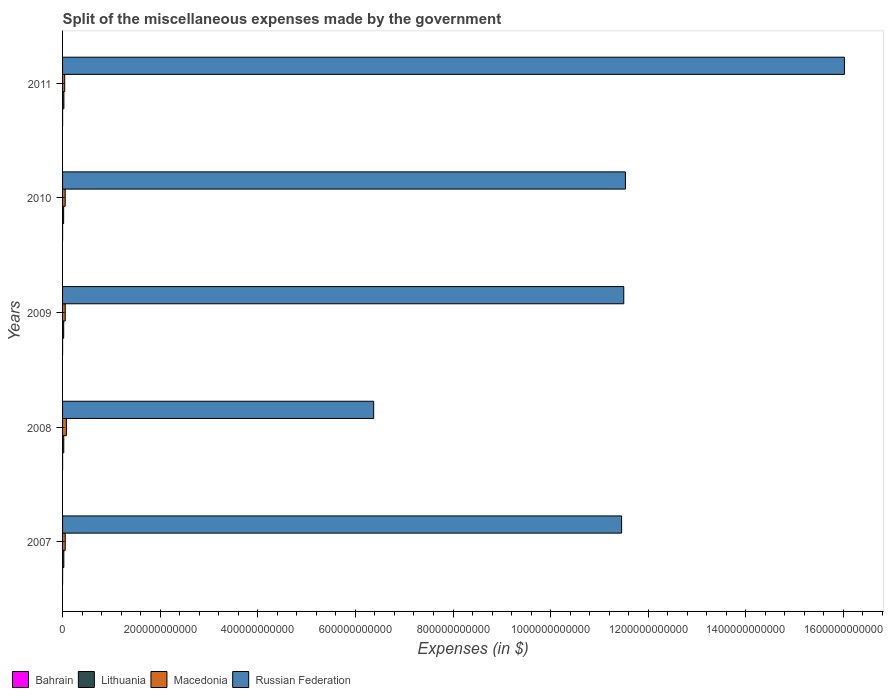How many different coloured bars are there?
Offer a terse response. 4. How many bars are there on the 5th tick from the top?
Give a very brief answer. 4. What is the label of the 3rd group of bars from the top?
Give a very brief answer. 2009. What is the miscellaneous expenses made by the government in Macedonia in 2011?
Offer a terse response. 4.39e+09. Across all years, what is the maximum miscellaneous expenses made by the government in Russian Federation?
Provide a succinct answer. 1.60e+12. Across all years, what is the minimum miscellaneous expenses made by the government in Macedonia?
Keep it short and to the point. 4.39e+09. In which year was the miscellaneous expenses made by the government in Bahrain maximum?
Ensure brevity in your answer.  2007. In which year was the miscellaneous expenses made by the government in Russian Federation minimum?
Ensure brevity in your answer.  2008. What is the total miscellaneous expenses made by the government in Russian Federation in the graph?
Make the answer very short. 5.69e+12. What is the difference between the miscellaneous expenses made by the government in Macedonia in 2009 and that in 2011?
Ensure brevity in your answer.  1.09e+09. What is the difference between the miscellaneous expenses made by the government in Bahrain in 2010 and the miscellaneous expenses made by the government in Macedonia in 2007?
Your response must be concise. -5.44e+09. What is the average miscellaneous expenses made by the government in Bahrain per year?
Keep it short and to the point. 3.77e+07. In the year 2008, what is the difference between the miscellaneous expenses made by the government in Russian Federation and miscellaneous expenses made by the government in Macedonia?
Provide a succinct answer. 6.30e+11. In how many years, is the miscellaneous expenses made by the government in Russian Federation greater than 160000000000 $?
Give a very brief answer. 5. What is the ratio of the miscellaneous expenses made by the government in Lithuania in 2007 to that in 2009?
Make the answer very short. 1.13. Is the difference between the miscellaneous expenses made by the government in Russian Federation in 2007 and 2010 greater than the difference between the miscellaneous expenses made by the government in Macedonia in 2007 and 2010?
Your answer should be compact. No. What is the difference between the highest and the second highest miscellaneous expenses made by the government in Lithuania?
Keep it short and to the point. 1.39e+08. What is the difference between the highest and the lowest miscellaneous expenses made by the government in Russian Federation?
Your answer should be very brief. 9.64e+11. Is the sum of the miscellaneous expenses made by the government in Lithuania in 2010 and 2011 greater than the maximum miscellaneous expenses made by the government in Bahrain across all years?
Make the answer very short. Yes. Is it the case that in every year, the sum of the miscellaneous expenses made by the government in Bahrain and miscellaneous expenses made by the government in Lithuania is greater than the sum of miscellaneous expenses made by the government in Russian Federation and miscellaneous expenses made by the government in Macedonia?
Provide a short and direct response. No. What does the 4th bar from the top in 2010 represents?
Keep it short and to the point. Bahrain. What does the 3rd bar from the bottom in 2010 represents?
Make the answer very short. Macedonia. Is it the case that in every year, the sum of the miscellaneous expenses made by the government in Russian Federation and miscellaneous expenses made by the government in Bahrain is greater than the miscellaneous expenses made by the government in Macedonia?
Keep it short and to the point. Yes. Are all the bars in the graph horizontal?
Make the answer very short. Yes. How many years are there in the graph?
Make the answer very short. 5. What is the difference between two consecutive major ticks on the X-axis?
Your answer should be very brief. 2.00e+11. Does the graph contain any zero values?
Your answer should be very brief. No. How many legend labels are there?
Make the answer very short. 4. What is the title of the graph?
Provide a short and direct response. Split of the miscellaneous expenses made by the government. Does "Virgin Islands" appear as one of the legend labels in the graph?
Your answer should be compact. No. What is the label or title of the X-axis?
Keep it short and to the point. Expenses (in $). What is the Expenses (in $) of Bahrain in 2007?
Offer a terse response. 5.97e+07. What is the Expenses (in $) of Lithuania in 2007?
Give a very brief answer. 2.58e+09. What is the Expenses (in $) in Macedonia in 2007?
Keep it short and to the point. 5.47e+09. What is the Expenses (in $) of Russian Federation in 2007?
Provide a short and direct response. 1.15e+12. What is the Expenses (in $) of Bahrain in 2008?
Your answer should be very brief. 1.90e+07. What is the Expenses (in $) of Lithuania in 2008?
Provide a succinct answer. 2.45e+09. What is the Expenses (in $) of Macedonia in 2008?
Offer a very short reply. 7.88e+09. What is the Expenses (in $) of Russian Federation in 2008?
Your answer should be very brief. 6.38e+11. What is the Expenses (in $) of Bahrain in 2009?
Make the answer very short. 2.67e+07. What is the Expenses (in $) in Lithuania in 2009?
Provide a short and direct response. 2.28e+09. What is the Expenses (in $) of Macedonia in 2009?
Your answer should be very brief. 5.48e+09. What is the Expenses (in $) in Russian Federation in 2009?
Give a very brief answer. 1.15e+12. What is the Expenses (in $) of Bahrain in 2010?
Provide a succinct answer. 2.50e+07. What is the Expenses (in $) of Lithuania in 2010?
Provide a succinct answer. 2.21e+09. What is the Expenses (in $) of Macedonia in 2010?
Provide a short and direct response. 5.39e+09. What is the Expenses (in $) in Russian Federation in 2010?
Your answer should be compact. 1.15e+12. What is the Expenses (in $) in Bahrain in 2011?
Give a very brief answer. 5.82e+07. What is the Expenses (in $) of Lithuania in 2011?
Give a very brief answer. 2.72e+09. What is the Expenses (in $) of Macedonia in 2011?
Make the answer very short. 4.39e+09. What is the Expenses (in $) in Russian Federation in 2011?
Ensure brevity in your answer.  1.60e+12. Across all years, what is the maximum Expenses (in $) of Bahrain?
Offer a very short reply. 5.97e+07. Across all years, what is the maximum Expenses (in $) in Lithuania?
Give a very brief answer. 2.72e+09. Across all years, what is the maximum Expenses (in $) in Macedonia?
Provide a succinct answer. 7.88e+09. Across all years, what is the maximum Expenses (in $) in Russian Federation?
Ensure brevity in your answer.  1.60e+12. Across all years, what is the minimum Expenses (in $) in Bahrain?
Offer a terse response. 1.90e+07. Across all years, what is the minimum Expenses (in $) of Lithuania?
Your answer should be very brief. 2.21e+09. Across all years, what is the minimum Expenses (in $) of Macedonia?
Your answer should be very brief. 4.39e+09. Across all years, what is the minimum Expenses (in $) in Russian Federation?
Your answer should be compact. 6.38e+11. What is the total Expenses (in $) in Bahrain in the graph?
Offer a very short reply. 1.89e+08. What is the total Expenses (in $) in Lithuania in the graph?
Your response must be concise. 1.22e+1. What is the total Expenses (in $) in Macedonia in the graph?
Make the answer very short. 2.86e+1. What is the total Expenses (in $) in Russian Federation in the graph?
Keep it short and to the point. 5.69e+12. What is the difference between the Expenses (in $) in Bahrain in 2007 and that in 2008?
Offer a terse response. 4.07e+07. What is the difference between the Expenses (in $) of Lithuania in 2007 and that in 2008?
Offer a terse response. 1.36e+08. What is the difference between the Expenses (in $) of Macedonia in 2007 and that in 2008?
Offer a terse response. -2.41e+09. What is the difference between the Expenses (in $) of Russian Federation in 2007 and that in 2008?
Make the answer very short. 5.08e+11. What is the difference between the Expenses (in $) in Bahrain in 2007 and that in 2009?
Your response must be concise. 3.30e+07. What is the difference between the Expenses (in $) in Lithuania in 2007 and that in 2009?
Offer a very short reply. 2.99e+08. What is the difference between the Expenses (in $) of Macedonia in 2007 and that in 2009?
Your answer should be compact. -1.40e+07. What is the difference between the Expenses (in $) of Russian Federation in 2007 and that in 2009?
Offer a very short reply. -4.40e+09. What is the difference between the Expenses (in $) in Bahrain in 2007 and that in 2010?
Your response must be concise. 3.47e+07. What is the difference between the Expenses (in $) in Lithuania in 2007 and that in 2010?
Your answer should be very brief. 3.74e+08. What is the difference between the Expenses (in $) in Macedonia in 2007 and that in 2010?
Your response must be concise. 7.30e+07. What is the difference between the Expenses (in $) in Russian Federation in 2007 and that in 2010?
Make the answer very short. -7.80e+09. What is the difference between the Expenses (in $) of Bahrain in 2007 and that in 2011?
Keep it short and to the point. 1.48e+06. What is the difference between the Expenses (in $) in Lithuania in 2007 and that in 2011?
Ensure brevity in your answer.  -1.39e+08. What is the difference between the Expenses (in $) in Macedonia in 2007 and that in 2011?
Keep it short and to the point. 1.08e+09. What is the difference between the Expenses (in $) in Russian Federation in 2007 and that in 2011?
Offer a very short reply. -4.56e+11. What is the difference between the Expenses (in $) of Bahrain in 2008 and that in 2009?
Ensure brevity in your answer.  -7.73e+06. What is the difference between the Expenses (in $) of Lithuania in 2008 and that in 2009?
Your answer should be compact. 1.64e+08. What is the difference between the Expenses (in $) in Macedonia in 2008 and that in 2009?
Keep it short and to the point. 2.40e+09. What is the difference between the Expenses (in $) of Russian Federation in 2008 and that in 2009?
Offer a very short reply. -5.12e+11. What is the difference between the Expenses (in $) of Bahrain in 2008 and that in 2010?
Provide a succinct answer. -6.02e+06. What is the difference between the Expenses (in $) of Lithuania in 2008 and that in 2010?
Your answer should be very brief. 2.38e+08. What is the difference between the Expenses (in $) in Macedonia in 2008 and that in 2010?
Ensure brevity in your answer.  2.48e+09. What is the difference between the Expenses (in $) in Russian Federation in 2008 and that in 2010?
Provide a short and direct response. -5.16e+11. What is the difference between the Expenses (in $) of Bahrain in 2008 and that in 2011?
Ensure brevity in your answer.  -3.92e+07. What is the difference between the Expenses (in $) in Lithuania in 2008 and that in 2011?
Offer a terse response. -2.75e+08. What is the difference between the Expenses (in $) of Macedonia in 2008 and that in 2011?
Give a very brief answer. 3.49e+09. What is the difference between the Expenses (in $) in Russian Federation in 2008 and that in 2011?
Offer a very short reply. -9.64e+11. What is the difference between the Expenses (in $) in Bahrain in 2009 and that in 2010?
Give a very brief answer. 1.71e+06. What is the difference between the Expenses (in $) in Lithuania in 2009 and that in 2010?
Offer a very short reply. 7.48e+07. What is the difference between the Expenses (in $) in Macedonia in 2009 and that in 2010?
Make the answer very short. 8.70e+07. What is the difference between the Expenses (in $) of Russian Federation in 2009 and that in 2010?
Keep it short and to the point. -3.40e+09. What is the difference between the Expenses (in $) of Bahrain in 2009 and that in 2011?
Ensure brevity in your answer.  -3.15e+07. What is the difference between the Expenses (in $) of Lithuania in 2009 and that in 2011?
Give a very brief answer. -4.38e+08. What is the difference between the Expenses (in $) of Macedonia in 2009 and that in 2011?
Your answer should be compact. 1.09e+09. What is the difference between the Expenses (in $) in Russian Federation in 2009 and that in 2011?
Offer a very short reply. -4.52e+11. What is the difference between the Expenses (in $) of Bahrain in 2010 and that in 2011?
Your response must be concise. -3.32e+07. What is the difference between the Expenses (in $) in Lithuania in 2010 and that in 2011?
Keep it short and to the point. -5.13e+08. What is the difference between the Expenses (in $) in Macedonia in 2010 and that in 2011?
Keep it short and to the point. 1.01e+09. What is the difference between the Expenses (in $) in Russian Federation in 2010 and that in 2011?
Provide a short and direct response. -4.49e+11. What is the difference between the Expenses (in $) of Bahrain in 2007 and the Expenses (in $) of Lithuania in 2008?
Your answer should be very brief. -2.39e+09. What is the difference between the Expenses (in $) of Bahrain in 2007 and the Expenses (in $) of Macedonia in 2008?
Offer a terse response. -7.82e+09. What is the difference between the Expenses (in $) in Bahrain in 2007 and the Expenses (in $) in Russian Federation in 2008?
Your answer should be very brief. -6.37e+11. What is the difference between the Expenses (in $) in Lithuania in 2007 and the Expenses (in $) in Macedonia in 2008?
Give a very brief answer. -5.29e+09. What is the difference between the Expenses (in $) in Lithuania in 2007 and the Expenses (in $) in Russian Federation in 2008?
Make the answer very short. -6.35e+11. What is the difference between the Expenses (in $) of Macedonia in 2007 and the Expenses (in $) of Russian Federation in 2008?
Provide a succinct answer. -6.32e+11. What is the difference between the Expenses (in $) of Bahrain in 2007 and the Expenses (in $) of Lithuania in 2009?
Your answer should be compact. -2.22e+09. What is the difference between the Expenses (in $) of Bahrain in 2007 and the Expenses (in $) of Macedonia in 2009?
Your answer should be very brief. -5.42e+09. What is the difference between the Expenses (in $) in Bahrain in 2007 and the Expenses (in $) in Russian Federation in 2009?
Ensure brevity in your answer.  -1.15e+12. What is the difference between the Expenses (in $) in Lithuania in 2007 and the Expenses (in $) in Macedonia in 2009?
Your response must be concise. -2.90e+09. What is the difference between the Expenses (in $) of Lithuania in 2007 and the Expenses (in $) of Russian Federation in 2009?
Your response must be concise. -1.15e+12. What is the difference between the Expenses (in $) of Macedonia in 2007 and the Expenses (in $) of Russian Federation in 2009?
Your answer should be compact. -1.14e+12. What is the difference between the Expenses (in $) in Bahrain in 2007 and the Expenses (in $) in Lithuania in 2010?
Give a very brief answer. -2.15e+09. What is the difference between the Expenses (in $) of Bahrain in 2007 and the Expenses (in $) of Macedonia in 2010?
Make the answer very short. -5.33e+09. What is the difference between the Expenses (in $) of Bahrain in 2007 and the Expenses (in $) of Russian Federation in 2010?
Give a very brief answer. -1.15e+12. What is the difference between the Expenses (in $) in Lithuania in 2007 and the Expenses (in $) in Macedonia in 2010?
Provide a short and direct response. -2.81e+09. What is the difference between the Expenses (in $) of Lithuania in 2007 and the Expenses (in $) of Russian Federation in 2010?
Your response must be concise. -1.15e+12. What is the difference between the Expenses (in $) of Macedonia in 2007 and the Expenses (in $) of Russian Federation in 2010?
Your answer should be very brief. -1.15e+12. What is the difference between the Expenses (in $) of Bahrain in 2007 and the Expenses (in $) of Lithuania in 2011?
Give a very brief answer. -2.66e+09. What is the difference between the Expenses (in $) of Bahrain in 2007 and the Expenses (in $) of Macedonia in 2011?
Make the answer very short. -4.33e+09. What is the difference between the Expenses (in $) in Bahrain in 2007 and the Expenses (in $) in Russian Federation in 2011?
Give a very brief answer. -1.60e+12. What is the difference between the Expenses (in $) in Lithuania in 2007 and the Expenses (in $) in Macedonia in 2011?
Provide a short and direct response. -1.80e+09. What is the difference between the Expenses (in $) in Lithuania in 2007 and the Expenses (in $) in Russian Federation in 2011?
Ensure brevity in your answer.  -1.60e+12. What is the difference between the Expenses (in $) in Macedonia in 2007 and the Expenses (in $) in Russian Federation in 2011?
Your answer should be very brief. -1.60e+12. What is the difference between the Expenses (in $) in Bahrain in 2008 and the Expenses (in $) in Lithuania in 2009?
Provide a succinct answer. -2.26e+09. What is the difference between the Expenses (in $) in Bahrain in 2008 and the Expenses (in $) in Macedonia in 2009?
Keep it short and to the point. -5.46e+09. What is the difference between the Expenses (in $) in Bahrain in 2008 and the Expenses (in $) in Russian Federation in 2009?
Ensure brevity in your answer.  -1.15e+12. What is the difference between the Expenses (in $) in Lithuania in 2008 and the Expenses (in $) in Macedonia in 2009?
Your answer should be compact. -3.03e+09. What is the difference between the Expenses (in $) of Lithuania in 2008 and the Expenses (in $) of Russian Federation in 2009?
Offer a very short reply. -1.15e+12. What is the difference between the Expenses (in $) of Macedonia in 2008 and the Expenses (in $) of Russian Federation in 2009?
Make the answer very short. -1.14e+12. What is the difference between the Expenses (in $) in Bahrain in 2008 and the Expenses (in $) in Lithuania in 2010?
Make the answer very short. -2.19e+09. What is the difference between the Expenses (in $) in Bahrain in 2008 and the Expenses (in $) in Macedonia in 2010?
Make the answer very short. -5.37e+09. What is the difference between the Expenses (in $) of Bahrain in 2008 and the Expenses (in $) of Russian Federation in 2010?
Your response must be concise. -1.15e+12. What is the difference between the Expenses (in $) in Lithuania in 2008 and the Expenses (in $) in Macedonia in 2010?
Your answer should be very brief. -2.95e+09. What is the difference between the Expenses (in $) in Lithuania in 2008 and the Expenses (in $) in Russian Federation in 2010?
Your answer should be compact. -1.15e+12. What is the difference between the Expenses (in $) in Macedonia in 2008 and the Expenses (in $) in Russian Federation in 2010?
Ensure brevity in your answer.  -1.15e+12. What is the difference between the Expenses (in $) in Bahrain in 2008 and the Expenses (in $) in Lithuania in 2011?
Keep it short and to the point. -2.70e+09. What is the difference between the Expenses (in $) in Bahrain in 2008 and the Expenses (in $) in Macedonia in 2011?
Your answer should be very brief. -4.37e+09. What is the difference between the Expenses (in $) of Bahrain in 2008 and the Expenses (in $) of Russian Federation in 2011?
Ensure brevity in your answer.  -1.60e+12. What is the difference between the Expenses (in $) in Lithuania in 2008 and the Expenses (in $) in Macedonia in 2011?
Provide a short and direct response. -1.94e+09. What is the difference between the Expenses (in $) of Lithuania in 2008 and the Expenses (in $) of Russian Federation in 2011?
Provide a succinct answer. -1.60e+12. What is the difference between the Expenses (in $) in Macedonia in 2008 and the Expenses (in $) in Russian Federation in 2011?
Keep it short and to the point. -1.59e+12. What is the difference between the Expenses (in $) of Bahrain in 2009 and the Expenses (in $) of Lithuania in 2010?
Offer a terse response. -2.18e+09. What is the difference between the Expenses (in $) of Bahrain in 2009 and the Expenses (in $) of Macedonia in 2010?
Keep it short and to the point. -5.37e+09. What is the difference between the Expenses (in $) in Bahrain in 2009 and the Expenses (in $) in Russian Federation in 2010?
Your answer should be very brief. -1.15e+12. What is the difference between the Expenses (in $) in Lithuania in 2009 and the Expenses (in $) in Macedonia in 2010?
Offer a very short reply. -3.11e+09. What is the difference between the Expenses (in $) of Lithuania in 2009 and the Expenses (in $) of Russian Federation in 2010?
Give a very brief answer. -1.15e+12. What is the difference between the Expenses (in $) of Macedonia in 2009 and the Expenses (in $) of Russian Federation in 2010?
Provide a short and direct response. -1.15e+12. What is the difference between the Expenses (in $) in Bahrain in 2009 and the Expenses (in $) in Lithuania in 2011?
Your answer should be compact. -2.70e+09. What is the difference between the Expenses (in $) of Bahrain in 2009 and the Expenses (in $) of Macedonia in 2011?
Provide a short and direct response. -4.36e+09. What is the difference between the Expenses (in $) in Bahrain in 2009 and the Expenses (in $) in Russian Federation in 2011?
Give a very brief answer. -1.60e+12. What is the difference between the Expenses (in $) of Lithuania in 2009 and the Expenses (in $) of Macedonia in 2011?
Offer a very short reply. -2.10e+09. What is the difference between the Expenses (in $) of Lithuania in 2009 and the Expenses (in $) of Russian Federation in 2011?
Provide a short and direct response. -1.60e+12. What is the difference between the Expenses (in $) of Macedonia in 2009 and the Expenses (in $) of Russian Federation in 2011?
Offer a very short reply. -1.60e+12. What is the difference between the Expenses (in $) in Bahrain in 2010 and the Expenses (in $) in Lithuania in 2011?
Keep it short and to the point. -2.70e+09. What is the difference between the Expenses (in $) of Bahrain in 2010 and the Expenses (in $) of Macedonia in 2011?
Offer a very short reply. -4.36e+09. What is the difference between the Expenses (in $) of Bahrain in 2010 and the Expenses (in $) of Russian Federation in 2011?
Provide a succinct answer. -1.60e+12. What is the difference between the Expenses (in $) in Lithuania in 2010 and the Expenses (in $) in Macedonia in 2011?
Your response must be concise. -2.18e+09. What is the difference between the Expenses (in $) in Lithuania in 2010 and the Expenses (in $) in Russian Federation in 2011?
Your answer should be compact. -1.60e+12. What is the difference between the Expenses (in $) in Macedonia in 2010 and the Expenses (in $) in Russian Federation in 2011?
Ensure brevity in your answer.  -1.60e+12. What is the average Expenses (in $) of Bahrain per year?
Keep it short and to the point. 3.77e+07. What is the average Expenses (in $) of Lithuania per year?
Give a very brief answer. 2.45e+09. What is the average Expenses (in $) in Macedonia per year?
Keep it short and to the point. 5.72e+09. What is the average Expenses (in $) of Russian Federation per year?
Your response must be concise. 1.14e+12. In the year 2007, what is the difference between the Expenses (in $) of Bahrain and Expenses (in $) of Lithuania?
Your answer should be very brief. -2.52e+09. In the year 2007, what is the difference between the Expenses (in $) in Bahrain and Expenses (in $) in Macedonia?
Keep it short and to the point. -5.41e+09. In the year 2007, what is the difference between the Expenses (in $) in Bahrain and Expenses (in $) in Russian Federation?
Ensure brevity in your answer.  -1.15e+12. In the year 2007, what is the difference between the Expenses (in $) of Lithuania and Expenses (in $) of Macedonia?
Keep it short and to the point. -2.88e+09. In the year 2007, what is the difference between the Expenses (in $) of Lithuania and Expenses (in $) of Russian Federation?
Keep it short and to the point. -1.14e+12. In the year 2007, what is the difference between the Expenses (in $) of Macedonia and Expenses (in $) of Russian Federation?
Offer a very short reply. -1.14e+12. In the year 2008, what is the difference between the Expenses (in $) in Bahrain and Expenses (in $) in Lithuania?
Your response must be concise. -2.43e+09. In the year 2008, what is the difference between the Expenses (in $) in Bahrain and Expenses (in $) in Macedonia?
Provide a short and direct response. -7.86e+09. In the year 2008, what is the difference between the Expenses (in $) in Bahrain and Expenses (in $) in Russian Federation?
Give a very brief answer. -6.37e+11. In the year 2008, what is the difference between the Expenses (in $) of Lithuania and Expenses (in $) of Macedonia?
Offer a very short reply. -5.43e+09. In the year 2008, what is the difference between the Expenses (in $) in Lithuania and Expenses (in $) in Russian Federation?
Make the answer very short. -6.35e+11. In the year 2008, what is the difference between the Expenses (in $) in Macedonia and Expenses (in $) in Russian Federation?
Make the answer very short. -6.30e+11. In the year 2009, what is the difference between the Expenses (in $) of Bahrain and Expenses (in $) of Lithuania?
Ensure brevity in your answer.  -2.26e+09. In the year 2009, what is the difference between the Expenses (in $) in Bahrain and Expenses (in $) in Macedonia?
Offer a very short reply. -5.45e+09. In the year 2009, what is the difference between the Expenses (in $) in Bahrain and Expenses (in $) in Russian Federation?
Keep it short and to the point. -1.15e+12. In the year 2009, what is the difference between the Expenses (in $) of Lithuania and Expenses (in $) of Macedonia?
Make the answer very short. -3.20e+09. In the year 2009, what is the difference between the Expenses (in $) in Lithuania and Expenses (in $) in Russian Federation?
Offer a terse response. -1.15e+12. In the year 2009, what is the difference between the Expenses (in $) of Macedonia and Expenses (in $) of Russian Federation?
Offer a very short reply. -1.14e+12. In the year 2010, what is the difference between the Expenses (in $) in Bahrain and Expenses (in $) in Lithuania?
Offer a very short reply. -2.18e+09. In the year 2010, what is the difference between the Expenses (in $) of Bahrain and Expenses (in $) of Macedonia?
Give a very brief answer. -5.37e+09. In the year 2010, what is the difference between the Expenses (in $) in Bahrain and Expenses (in $) in Russian Federation?
Provide a succinct answer. -1.15e+12. In the year 2010, what is the difference between the Expenses (in $) of Lithuania and Expenses (in $) of Macedonia?
Provide a short and direct response. -3.18e+09. In the year 2010, what is the difference between the Expenses (in $) in Lithuania and Expenses (in $) in Russian Federation?
Make the answer very short. -1.15e+12. In the year 2010, what is the difference between the Expenses (in $) of Macedonia and Expenses (in $) of Russian Federation?
Offer a very short reply. -1.15e+12. In the year 2011, what is the difference between the Expenses (in $) of Bahrain and Expenses (in $) of Lithuania?
Offer a terse response. -2.66e+09. In the year 2011, what is the difference between the Expenses (in $) of Bahrain and Expenses (in $) of Macedonia?
Your answer should be very brief. -4.33e+09. In the year 2011, what is the difference between the Expenses (in $) in Bahrain and Expenses (in $) in Russian Federation?
Give a very brief answer. -1.60e+12. In the year 2011, what is the difference between the Expenses (in $) of Lithuania and Expenses (in $) of Macedonia?
Offer a very short reply. -1.67e+09. In the year 2011, what is the difference between the Expenses (in $) in Lithuania and Expenses (in $) in Russian Federation?
Offer a very short reply. -1.60e+12. In the year 2011, what is the difference between the Expenses (in $) of Macedonia and Expenses (in $) of Russian Federation?
Provide a short and direct response. -1.60e+12. What is the ratio of the Expenses (in $) of Bahrain in 2007 to that in 2008?
Your answer should be very brief. 3.15. What is the ratio of the Expenses (in $) in Lithuania in 2007 to that in 2008?
Your response must be concise. 1.06. What is the ratio of the Expenses (in $) of Macedonia in 2007 to that in 2008?
Offer a terse response. 0.69. What is the ratio of the Expenses (in $) in Russian Federation in 2007 to that in 2008?
Ensure brevity in your answer.  1.8. What is the ratio of the Expenses (in $) in Bahrain in 2007 to that in 2009?
Provide a short and direct response. 2.24. What is the ratio of the Expenses (in $) in Lithuania in 2007 to that in 2009?
Offer a very short reply. 1.13. What is the ratio of the Expenses (in $) of Russian Federation in 2007 to that in 2009?
Your response must be concise. 1. What is the ratio of the Expenses (in $) of Bahrain in 2007 to that in 2010?
Your answer should be compact. 2.39. What is the ratio of the Expenses (in $) of Lithuania in 2007 to that in 2010?
Your answer should be very brief. 1.17. What is the ratio of the Expenses (in $) in Macedonia in 2007 to that in 2010?
Make the answer very short. 1.01. What is the ratio of the Expenses (in $) of Bahrain in 2007 to that in 2011?
Offer a terse response. 1.03. What is the ratio of the Expenses (in $) of Lithuania in 2007 to that in 2011?
Ensure brevity in your answer.  0.95. What is the ratio of the Expenses (in $) in Macedonia in 2007 to that in 2011?
Offer a very short reply. 1.25. What is the ratio of the Expenses (in $) in Russian Federation in 2007 to that in 2011?
Offer a terse response. 0.71. What is the ratio of the Expenses (in $) of Bahrain in 2008 to that in 2009?
Your response must be concise. 0.71. What is the ratio of the Expenses (in $) of Lithuania in 2008 to that in 2009?
Make the answer very short. 1.07. What is the ratio of the Expenses (in $) of Macedonia in 2008 to that in 2009?
Ensure brevity in your answer.  1.44. What is the ratio of the Expenses (in $) of Russian Federation in 2008 to that in 2009?
Give a very brief answer. 0.55. What is the ratio of the Expenses (in $) in Bahrain in 2008 to that in 2010?
Keep it short and to the point. 0.76. What is the ratio of the Expenses (in $) of Lithuania in 2008 to that in 2010?
Offer a terse response. 1.11. What is the ratio of the Expenses (in $) in Macedonia in 2008 to that in 2010?
Provide a short and direct response. 1.46. What is the ratio of the Expenses (in $) of Russian Federation in 2008 to that in 2010?
Give a very brief answer. 0.55. What is the ratio of the Expenses (in $) in Bahrain in 2008 to that in 2011?
Provide a short and direct response. 0.33. What is the ratio of the Expenses (in $) in Lithuania in 2008 to that in 2011?
Your answer should be very brief. 0.9. What is the ratio of the Expenses (in $) in Macedonia in 2008 to that in 2011?
Provide a succinct answer. 1.8. What is the ratio of the Expenses (in $) in Russian Federation in 2008 to that in 2011?
Offer a terse response. 0.4. What is the ratio of the Expenses (in $) in Bahrain in 2009 to that in 2010?
Keep it short and to the point. 1.07. What is the ratio of the Expenses (in $) in Lithuania in 2009 to that in 2010?
Offer a terse response. 1.03. What is the ratio of the Expenses (in $) of Macedonia in 2009 to that in 2010?
Make the answer very short. 1.02. What is the ratio of the Expenses (in $) of Russian Federation in 2009 to that in 2010?
Ensure brevity in your answer.  1. What is the ratio of the Expenses (in $) in Bahrain in 2009 to that in 2011?
Give a very brief answer. 0.46. What is the ratio of the Expenses (in $) in Lithuania in 2009 to that in 2011?
Offer a very short reply. 0.84. What is the ratio of the Expenses (in $) of Macedonia in 2009 to that in 2011?
Keep it short and to the point. 1.25. What is the ratio of the Expenses (in $) in Russian Federation in 2009 to that in 2011?
Your response must be concise. 0.72. What is the ratio of the Expenses (in $) in Bahrain in 2010 to that in 2011?
Keep it short and to the point. 0.43. What is the ratio of the Expenses (in $) in Lithuania in 2010 to that in 2011?
Give a very brief answer. 0.81. What is the ratio of the Expenses (in $) of Macedonia in 2010 to that in 2011?
Your answer should be very brief. 1.23. What is the ratio of the Expenses (in $) of Russian Federation in 2010 to that in 2011?
Make the answer very short. 0.72. What is the difference between the highest and the second highest Expenses (in $) in Bahrain?
Provide a succinct answer. 1.48e+06. What is the difference between the highest and the second highest Expenses (in $) in Lithuania?
Provide a succinct answer. 1.39e+08. What is the difference between the highest and the second highest Expenses (in $) of Macedonia?
Offer a very short reply. 2.40e+09. What is the difference between the highest and the second highest Expenses (in $) in Russian Federation?
Your response must be concise. 4.49e+11. What is the difference between the highest and the lowest Expenses (in $) of Bahrain?
Ensure brevity in your answer.  4.07e+07. What is the difference between the highest and the lowest Expenses (in $) in Lithuania?
Your answer should be very brief. 5.13e+08. What is the difference between the highest and the lowest Expenses (in $) of Macedonia?
Keep it short and to the point. 3.49e+09. What is the difference between the highest and the lowest Expenses (in $) in Russian Federation?
Provide a short and direct response. 9.64e+11. 